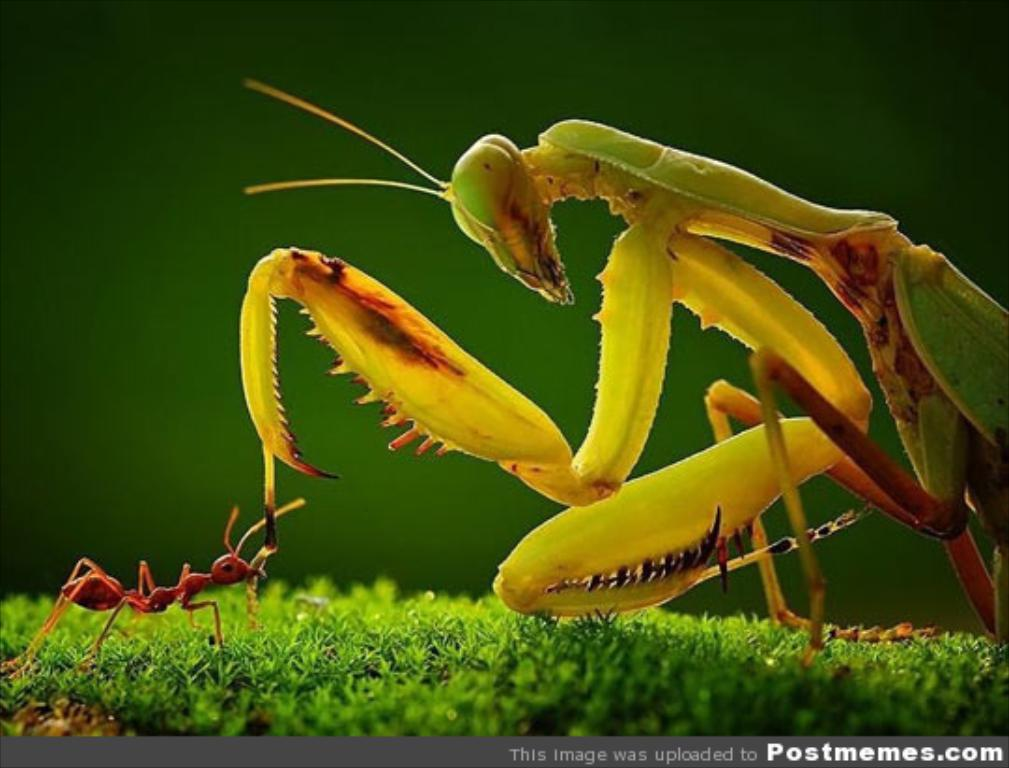What type of creature is present in the image? There is an insect in the image. What colors can be seen on the insect? The insect has green, yellow, and red colors. What type of vegetation is visible in the image? There is grass in the image. Can you describe the appearance of another insect in the image? There is a red color ant in the image. What color is the background of the image? The background of the image is green. Does the insect have a tail in the image? No, insects do not have tails, so there is no tail present in the image. 